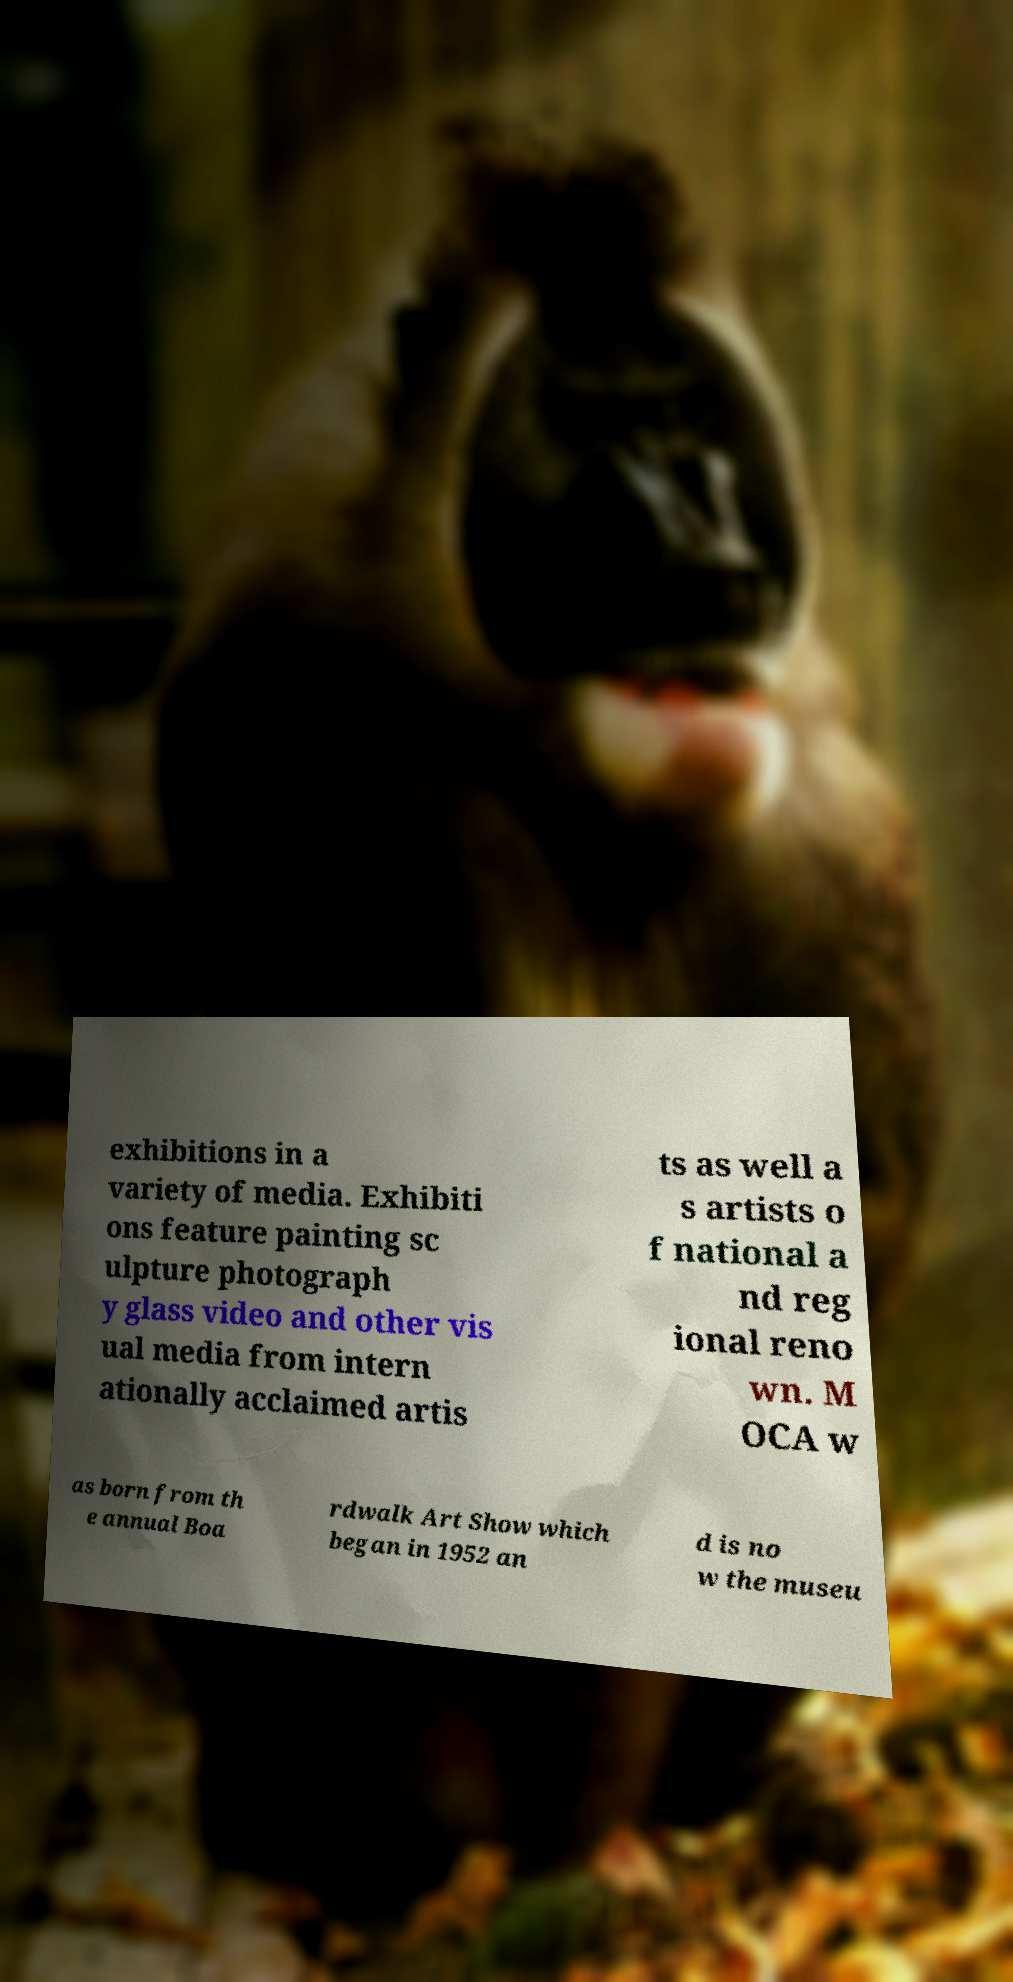I need the written content from this picture converted into text. Can you do that? exhibitions in a variety of media. Exhibiti ons feature painting sc ulpture photograph y glass video and other vis ual media from intern ationally acclaimed artis ts as well a s artists o f national a nd reg ional reno wn. M OCA w as born from th e annual Boa rdwalk Art Show which began in 1952 an d is no w the museu 